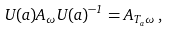<formula> <loc_0><loc_0><loc_500><loc_500>U ( a ) A _ { \omega } U ( a ) ^ { - 1 } = A _ { T _ { a } \omega } \, ,</formula> 